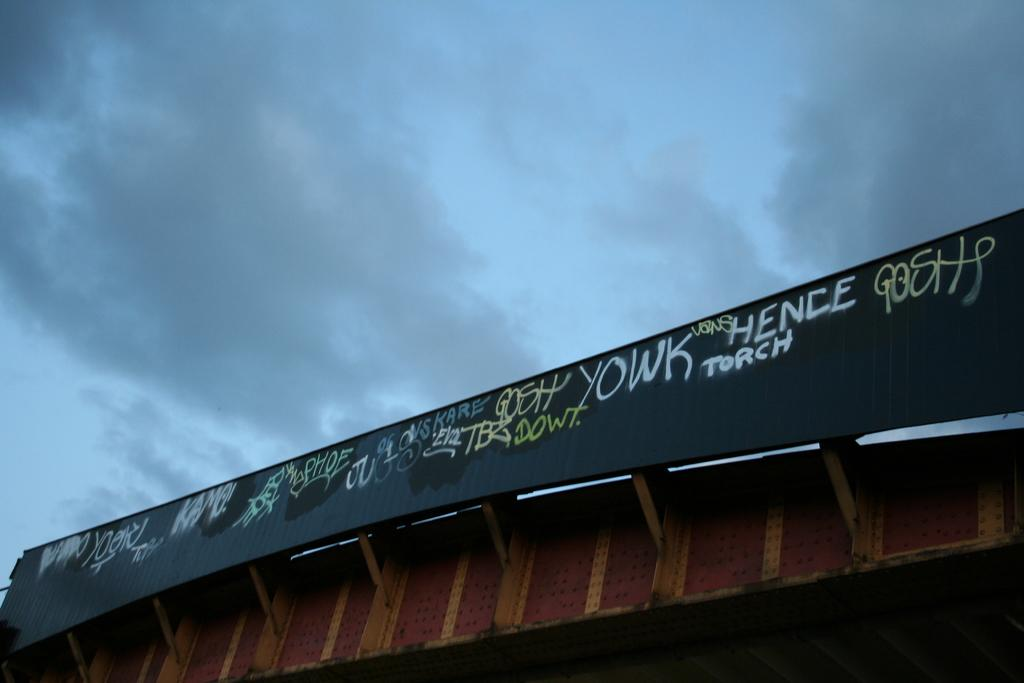What is the main object in the image? There is a hoarding board in the image. Where is the hoarding board located? The hoarding board appears to be on the roof of a metal shed. What can be seen in the background of the image? The sky is visible in the image. What is the condition of the sky in the image? Clouds are present in the sky. What type of bead is used to create harmony in the image? There is no bead or reference to harmony in the image; it features a hoarding board on a metal shed with clouds in the sky. 